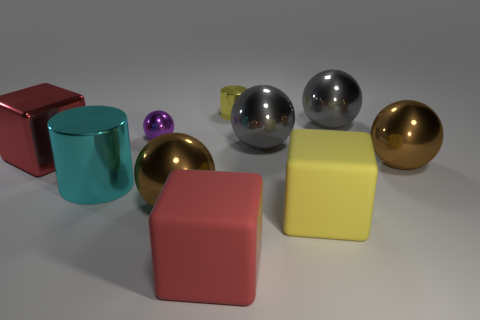Subtract all blue cubes. How many brown spheres are left? 2 Subtract all tiny purple metallic spheres. How many spheres are left? 4 Subtract all purple spheres. How many spheres are left? 4 Subtract 1 balls. How many balls are left? 4 Subtract all purple spheres. Subtract all gray cylinders. How many spheres are left? 4 Subtract all cylinders. How many objects are left? 8 Add 2 big rubber objects. How many big rubber objects exist? 4 Subtract 0 purple cubes. How many objects are left? 10 Subtract all large cyan metallic cylinders. Subtract all large yellow objects. How many objects are left? 8 Add 3 big balls. How many big balls are left? 7 